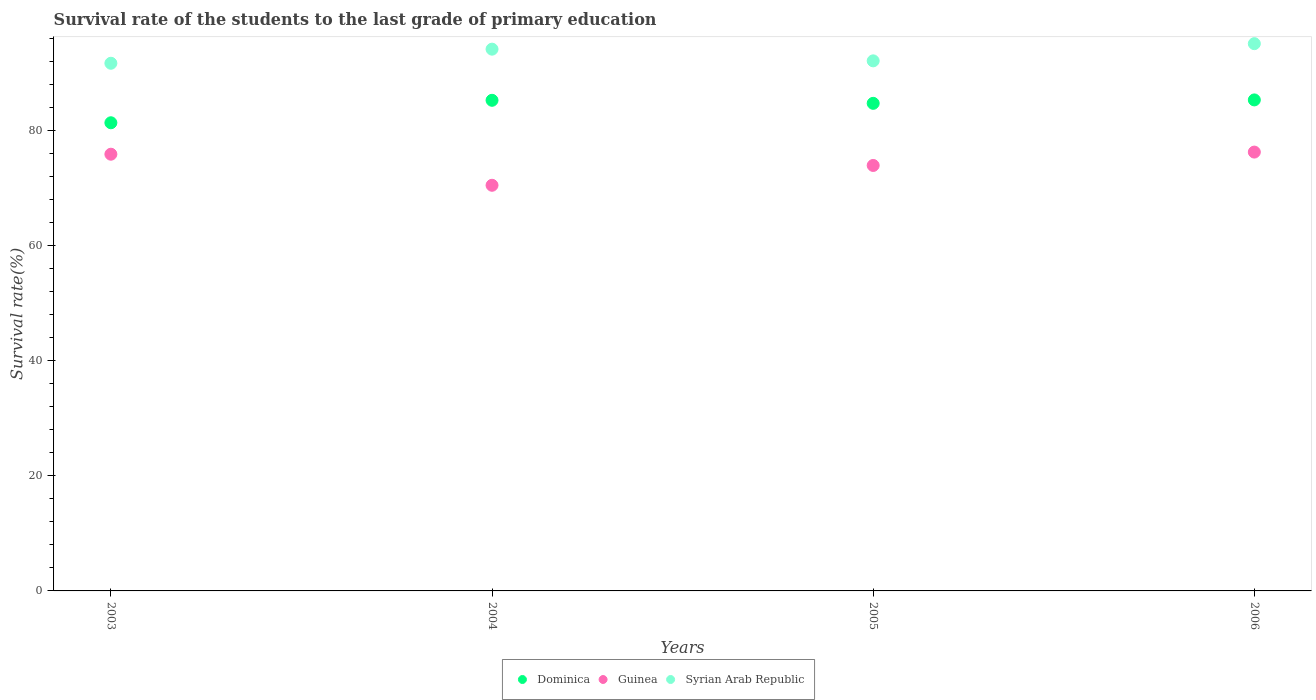How many different coloured dotlines are there?
Offer a very short reply. 3. Is the number of dotlines equal to the number of legend labels?
Make the answer very short. Yes. What is the survival rate of the students in Syrian Arab Republic in 2003?
Ensure brevity in your answer.  91.76. Across all years, what is the maximum survival rate of the students in Syrian Arab Republic?
Offer a terse response. 95.17. Across all years, what is the minimum survival rate of the students in Syrian Arab Republic?
Offer a terse response. 91.76. What is the total survival rate of the students in Syrian Arab Republic in the graph?
Make the answer very short. 373.33. What is the difference between the survival rate of the students in Guinea in 2005 and that in 2006?
Your answer should be very brief. -2.33. What is the difference between the survival rate of the students in Guinea in 2006 and the survival rate of the students in Syrian Arab Republic in 2005?
Your answer should be compact. -15.86. What is the average survival rate of the students in Dominica per year?
Ensure brevity in your answer.  84.23. In the year 2005, what is the difference between the survival rate of the students in Dominica and survival rate of the students in Guinea?
Give a very brief answer. 10.8. In how many years, is the survival rate of the students in Syrian Arab Republic greater than 28 %?
Ensure brevity in your answer.  4. What is the ratio of the survival rate of the students in Syrian Arab Republic in 2003 to that in 2005?
Your answer should be compact. 1. Is the difference between the survival rate of the students in Dominica in 2004 and 2006 greater than the difference between the survival rate of the students in Guinea in 2004 and 2006?
Keep it short and to the point. Yes. What is the difference between the highest and the second highest survival rate of the students in Syrian Arab Republic?
Keep it short and to the point. 0.96. What is the difference between the highest and the lowest survival rate of the students in Dominica?
Your answer should be very brief. 3.97. Is it the case that in every year, the sum of the survival rate of the students in Guinea and survival rate of the students in Syrian Arab Republic  is greater than the survival rate of the students in Dominica?
Offer a terse response. Yes. Does the survival rate of the students in Dominica monotonically increase over the years?
Offer a terse response. No. Is the survival rate of the students in Guinea strictly greater than the survival rate of the students in Syrian Arab Republic over the years?
Offer a very short reply. No. How many dotlines are there?
Your answer should be very brief. 3. Where does the legend appear in the graph?
Provide a succinct answer. Bottom center. How many legend labels are there?
Ensure brevity in your answer.  3. What is the title of the graph?
Keep it short and to the point. Survival rate of the students to the last grade of primary education. What is the label or title of the X-axis?
Give a very brief answer. Years. What is the label or title of the Y-axis?
Offer a very short reply. Survival rate(%). What is the Survival rate(%) in Dominica in 2003?
Your answer should be compact. 81.41. What is the Survival rate(%) in Guinea in 2003?
Your answer should be very brief. 75.94. What is the Survival rate(%) of Syrian Arab Republic in 2003?
Offer a terse response. 91.76. What is the Survival rate(%) of Dominica in 2004?
Make the answer very short. 85.32. What is the Survival rate(%) of Guinea in 2004?
Your answer should be very brief. 70.54. What is the Survival rate(%) in Syrian Arab Republic in 2004?
Keep it short and to the point. 94.21. What is the Survival rate(%) of Dominica in 2005?
Give a very brief answer. 84.79. What is the Survival rate(%) in Guinea in 2005?
Make the answer very short. 73.99. What is the Survival rate(%) in Syrian Arab Republic in 2005?
Keep it short and to the point. 92.18. What is the Survival rate(%) of Dominica in 2006?
Offer a terse response. 85.39. What is the Survival rate(%) of Guinea in 2006?
Your response must be concise. 76.32. What is the Survival rate(%) of Syrian Arab Republic in 2006?
Your response must be concise. 95.17. Across all years, what is the maximum Survival rate(%) of Dominica?
Provide a succinct answer. 85.39. Across all years, what is the maximum Survival rate(%) of Guinea?
Your answer should be very brief. 76.32. Across all years, what is the maximum Survival rate(%) in Syrian Arab Republic?
Your answer should be compact. 95.17. Across all years, what is the minimum Survival rate(%) of Dominica?
Offer a terse response. 81.41. Across all years, what is the minimum Survival rate(%) of Guinea?
Offer a very short reply. 70.54. Across all years, what is the minimum Survival rate(%) of Syrian Arab Republic?
Your answer should be very brief. 91.76. What is the total Survival rate(%) of Dominica in the graph?
Your answer should be very brief. 336.91. What is the total Survival rate(%) in Guinea in the graph?
Offer a very short reply. 296.79. What is the total Survival rate(%) of Syrian Arab Republic in the graph?
Provide a short and direct response. 373.33. What is the difference between the Survival rate(%) of Dominica in 2003 and that in 2004?
Your response must be concise. -3.91. What is the difference between the Survival rate(%) of Guinea in 2003 and that in 2004?
Your response must be concise. 5.4. What is the difference between the Survival rate(%) in Syrian Arab Republic in 2003 and that in 2004?
Give a very brief answer. -2.45. What is the difference between the Survival rate(%) of Dominica in 2003 and that in 2005?
Ensure brevity in your answer.  -3.38. What is the difference between the Survival rate(%) of Guinea in 2003 and that in 2005?
Provide a succinct answer. 1.95. What is the difference between the Survival rate(%) of Syrian Arab Republic in 2003 and that in 2005?
Your response must be concise. -0.42. What is the difference between the Survival rate(%) in Dominica in 2003 and that in 2006?
Provide a succinct answer. -3.97. What is the difference between the Survival rate(%) in Guinea in 2003 and that in 2006?
Your answer should be very brief. -0.37. What is the difference between the Survival rate(%) of Syrian Arab Republic in 2003 and that in 2006?
Offer a very short reply. -3.41. What is the difference between the Survival rate(%) of Dominica in 2004 and that in 2005?
Offer a very short reply. 0.53. What is the difference between the Survival rate(%) in Guinea in 2004 and that in 2005?
Provide a short and direct response. -3.45. What is the difference between the Survival rate(%) in Syrian Arab Republic in 2004 and that in 2005?
Ensure brevity in your answer.  2.03. What is the difference between the Survival rate(%) of Dominica in 2004 and that in 2006?
Offer a terse response. -0.07. What is the difference between the Survival rate(%) of Guinea in 2004 and that in 2006?
Give a very brief answer. -5.77. What is the difference between the Survival rate(%) of Syrian Arab Republic in 2004 and that in 2006?
Your answer should be very brief. -0.96. What is the difference between the Survival rate(%) of Dominica in 2005 and that in 2006?
Provide a succinct answer. -0.59. What is the difference between the Survival rate(%) in Guinea in 2005 and that in 2006?
Your answer should be compact. -2.33. What is the difference between the Survival rate(%) in Syrian Arab Republic in 2005 and that in 2006?
Offer a terse response. -2.99. What is the difference between the Survival rate(%) of Dominica in 2003 and the Survival rate(%) of Guinea in 2004?
Give a very brief answer. 10.87. What is the difference between the Survival rate(%) of Dominica in 2003 and the Survival rate(%) of Syrian Arab Republic in 2004?
Keep it short and to the point. -12.8. What is the difference between the Survival rate(%) of Guinea in 2003 and the Survival rate(%) of Syrian Arab Republic in 2004?
Provide a short and direct response. -18.27. What is the difference between the Survival rate(%) in Dominica in 2003 and the Survival rate(%) in Guinea in 2005?
Provide a short and direct response. 7.42. What is the difference between the Survival rate(%) of Dominica in 2003 and the Survival rate(%) of Syrian Arab Republic in 2005?
Your response must be concise. -10.77. What is the difference between the Survival rate(%) of Guinea in 2003 and the Survival rate(%) of Syrian Arab Republic in 2005?
Give a very brief answer. -16.24. What is the difference between the Survival rate(%) of Dominica in 2003 and the Survival rate(%) of Guinea in 2006?
Provide a succinct answer. 5.1. What is the difference between the Survival rate(%) of Dominica in 2003 and the Survival rate(%) of Syrian Arab Republic in 2006?
Offer a very short reply. -13.76. What is the difference between the Survival rate(%) in Guinea in 2003 and the Survival rate(%) in Syrian Arab Republic in 2006?
Provide a succinct answer. -19.23. What is the difference between the Survival rate(%) in Dominica in 2004 and the Survival rate(%) in Guinea in 2005?
Provide a short and direct response. 11.33. What is the difference between the Survival rate(%) of Dominica in 2004 and the Survival rate(%) of Syrian Arab Republic in 2005?
Your answer should be compact. -6.86. What is the difference between the Survival rate(%) of Guinea in 2004 and the Survival rate(%) of Syrian Arab Republic in 2005?
Offer a terse response. -21.64. What is the difference between the Survival rate(%) in Dominica in 2004 and the Survival rate(%) in Guinea in 2006?
Provide a short and direct response. 9.01. What is the difference between the Survival rate(%) in Dominica in 2004 and the Survival rate(%) in Syrian Arab Republic in 2006?
Offer a very short reply. -9.85. What is the difference between the Survival rate(%) of Guinea in 2004 and the Survival rate(%) of Syrian Arab Republic in 2006?
Give a very brief answer. -24.63. What is the difference between the Survival rate(%) in Dominica in 2005 and the Survival rate(%) in Guinea in 2006?
Offer a very short reply. 8.48. What is the difference between the Survival rate(%) in Dominica in 2005 and the Survival rate(%) in Syrian Arab Republic in 2006?
Provide a succinct answer. -10.38. What is the difference between the Survival rate(%) of Guinea in 2005 and the Survival rate(%) of Syrian Arab Republic in 2006?
Your answer should be very brief. -21.18. What is the average Survival rate(%) of Dominica per year?
Give a very brief answer. 84.23. What is the average Survival rate(%) of Guinea per year?
Offer a very short reply. 74.2. What is the average Survival rate(%) of Syrian Arab Republic per year?
Provide a short and direct response. 93.33. In the year 2003, what is the difference between the Survival rate(%) of Dominica and Survival rate(%) of Guinea?
Your response must be concise. 5.47. In the year 2003, what is the difference between the Survival rate(%) of Dominica and Survival rate(%) of Syrian Arab Republic?
Your response must be concise. -10.35. In the year 2003, what is the difference between the Survival rate(%) in Guinea and Survival rate(%) in Syrian Arab Republic?
Your response must be concise. -15.82. In the year 2004, what is the difference between the Survival rate(%) in Dominica and Survival rate(%) in Guinea?
Your answer should be very brief. 14.78. In the year 2004, what is the difference between the Survival rate(%) in Dominica and Survival rate(%) in Syrian Arab Republic?
Your answer should be very brief. -8.89. In the year 2004, what is the difference between the Survival rate(%) in Guinea and Survival rate(%) in Syrian Arab Republic?
Provide a succinct answer. -23.67. In the year 2005, what is the difference between the Survival rate(%) of Dominica and Survival rate(%) of Guinea?
Your answer should be compact. 10.8. In the year 2005, what is the difference between the Survival rate(%) of Dominica and Survival rate(%) of Syrian Arab Republic?
Keep it short and to the point. -7.39. In the year 2005, what is the difference between the Survival rate(%) in Guinea and Survival rate(%) in Syrian Arab Republic?
Your answer should be very brief. -18.19. In the year 2006, what is the difference between the Survival rate(%) of Dominica and Survival rate(%) of Guinea?
Your response must be concise. 9.07. In the year 2006, what is the difference between the Survival rate(%) of Dominica and Survival rate(%) of Syrian Arab Republic?
Make the answer very short. -9.78. In the year 2006, what is the difference between the Survival rate(%) of Guinea and Survival rate(%) of Syrian Arab Republic?
Provide a short and direct response. -18.86. What is the ratio of the Survival rate(%) in Dominica in 2003 to that in 2004?
Keep it short and to the point. 0.95. What is the ratio of the Survival rate(%) in Guinea in 2003 to that in 2004?
Your answer should be compact. 1.08. What is the ratio of the Survival rate(%) of Dominica in 2003 to that in 2005?
Make the answer very short. 0.96. What is the ratio of the Survival rate(%) in Guinea in 2003 to that in 2005?
Keep it short and to the point. 1.03. What is the ratio of the Survival rate(%) in Dominica in 2003 to that in 2006?
Keep it short and to the point. 0.95. What is the ratio of the Survival rate(%) of Syrian Arab Republic in 2003 to that in 2006?
Ensure brevity in your answer.  0.96. What is the ratio of the Survival rate(%) of Dominica in 2004 to that in 2005?
Provide a short and direct response. 1.01. What is the ratio of the Survival rate(%) in Guinea in 2004 to that in 2005?
Provide a short and direct response. 0.95. What is the ratio of the Survival rate(%) of Syrian Arab Republic in 2004 to that in 2005?
Keep it short and to the point. 1.02. What is the ratio of the Survival rate(%) in Dominica in 2004 to that in 2006?
Your response must be concise. 1. What is the ratio of the Survival rate(%) in Guinea in 2004 to that in 2006?
Your answer should be very brief. 0.92. What is the ratio of the Survival rate(%) of Syrian Arab Republic in 2004 to that in 2006?
Provide a short and direct response. 0.99. What is the ratio of the Survival rate(%) of Dominica in 2005 to that in 2006?
Give a very brief answer. 0.99. What is the ratio of the Survival rate(%) in Guinea in 2005 to that in 2006?
Your response must be concise. 0.97. What is the ratio of the Survival rate(%) of Syrian Arab Republic in 2005 to that in 2006?
Offer a terse response. 0.97. What is the difference between the highest and the second highest Survival rate(%) in Dominica?
Your response must be concise. 0.07. What is the difference between the highest and the second highest Survival rate(%) of Guinea?
Make the answer very short. 0.37. What is the difference between the highest and the second highest Survival rate(%) of Syrian Arab Republic?
Give a very brief answer. 0.96. What is the difference between the highest and the lowest Survival rate(%) of Dominica?
Make the answer very short. 3.97. What is the difference between the highest and the lowest Survival rate(%) in Guinea?
Give a very brief answer. 5.77. What is the difference between the highest and the lowest Survival rate(%) of Syrian Arab Republic?
Offer a terse response. 3.41. 